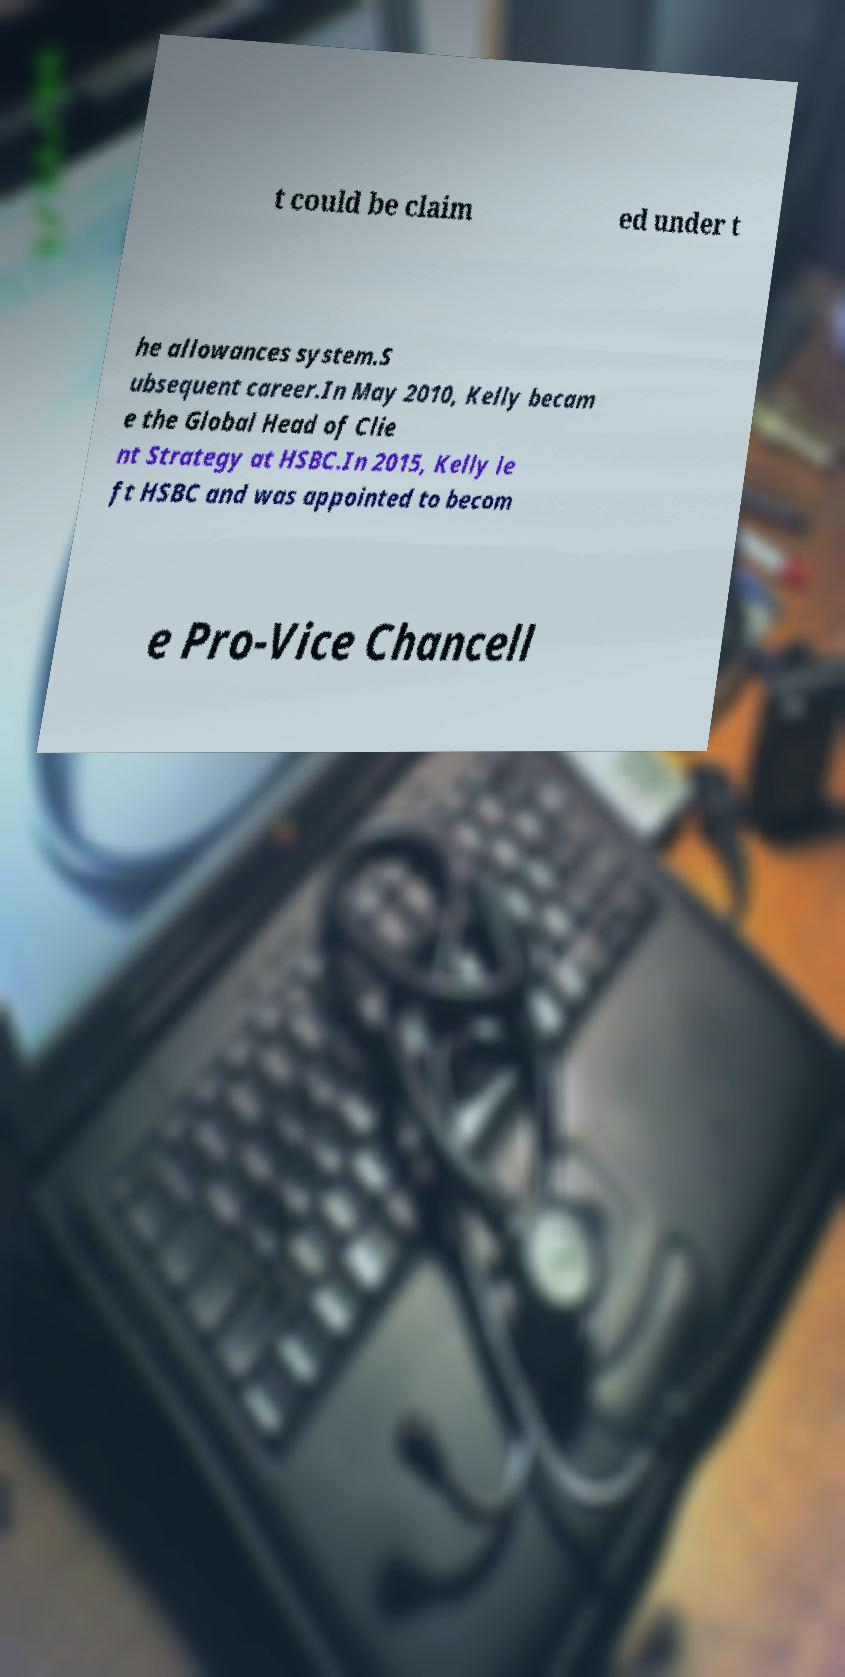Could you extract and type out the text from this image? t could be claim ed under t he allowances system.S ubsequent career.In May 2010, Kelly becam e the Global Head of Clie nt Strategy at HSBC.In 2015, Kelly le ft HSBC and was appointed to becom e Pro-Vice Chancell 